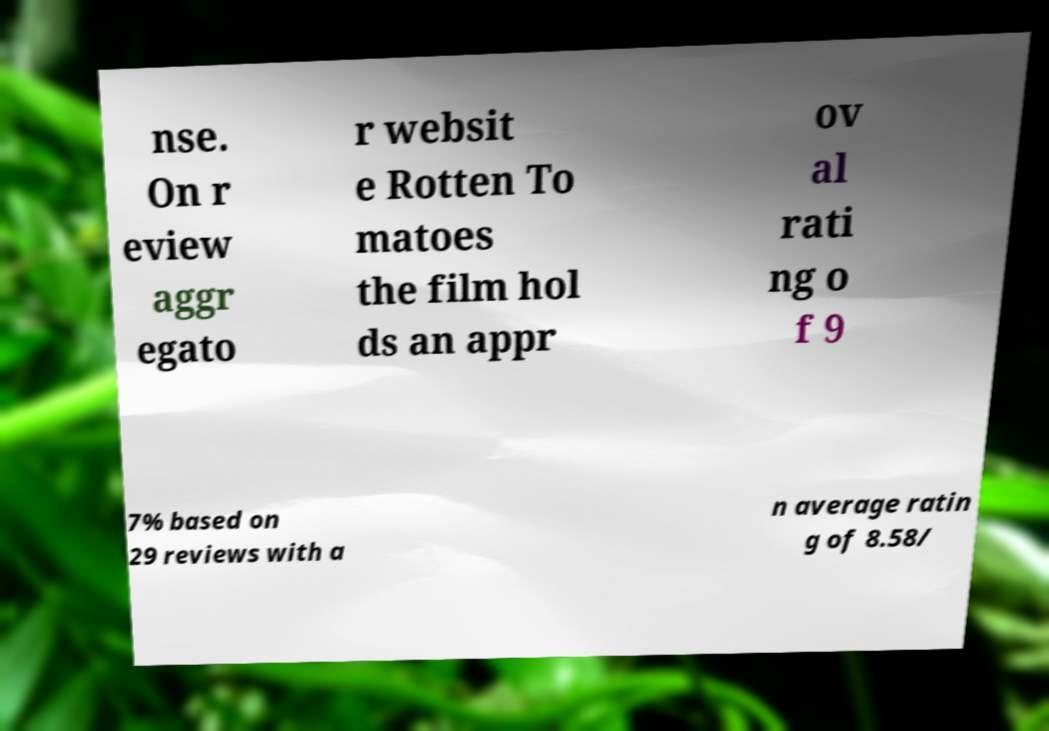Can you accurately transcribe the text from the provided image for me? nse. On r eview aggr egato r websit e Rotten To matoes the film hol ds an appr ov al rati ng o f 9 7% based on 29 reviews with a n average ratin g of 8.58/ 